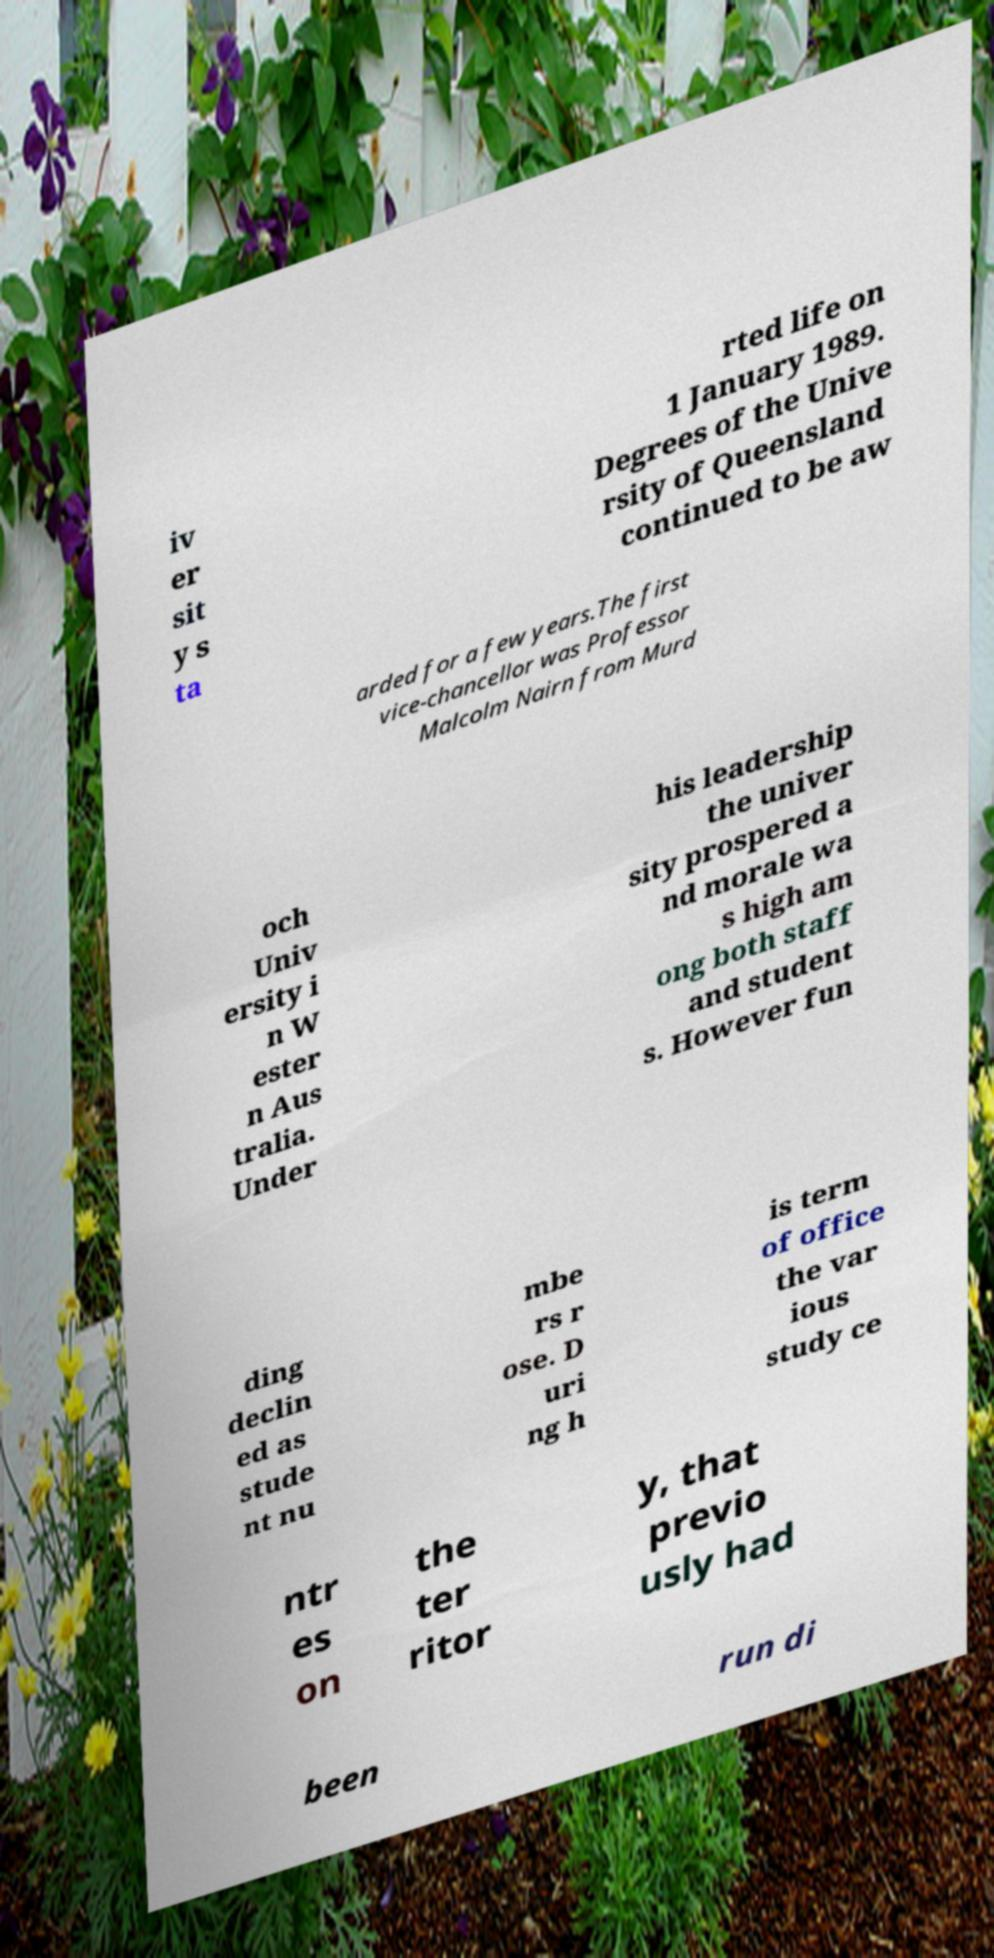Please read and relay the text visible in this image. What does it say? iv er sit y s ta rted life on 1 January 1989. Degrees of the Unive rsity of Queensland continued to be aw arded for a few years.The first vice-chancellor was Professor Malcolm Nairn from Murd och Univ ersity i n W ester n Aus tralia. Under his leadership the univer sity prospered a nd morale wa s high am ong both staff and student s. However fun ding declin ed as stude nt nu mbe rs r ose. D uri ng h is term of office the var ious study ce ntr es on the ter ritor y, that previo usly had been run di 